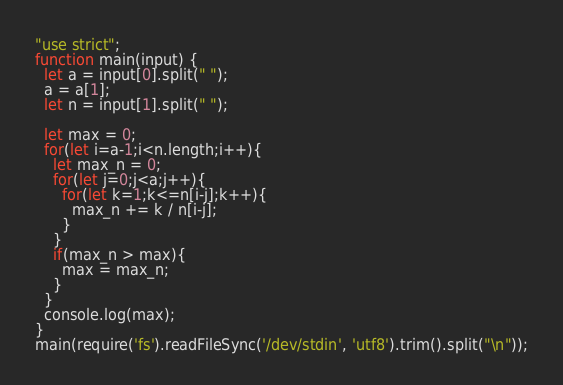<code> <loc_0><loc_0><loc_500><loc_500><_JavaScript_>"use strict";
function main(input) {
  let a = input[0].split(" ");
  a = a[1];
  let n = input[1].split(" ");
  
  let max = 0;
  for(let i=a-1;i<n.length;i++){
    let max_n = 0;
    for(let j=0;j<a;j++){
      for(let k=1;k<=n[i-j];k++){
        max_n += k / n[i-j];
      }
    }
    if(max_n > max){
      max = max_n;
    }
  }
  console.log(max);
}
main(require('fs').readFileSync('/dev/stdin', 'utf8').trim().split("\n"));</code> 